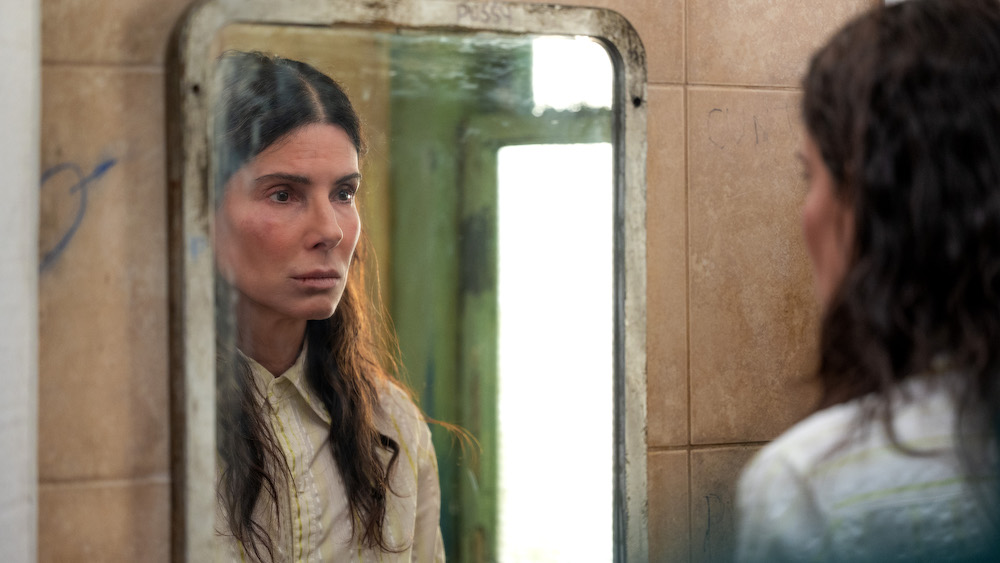Craft a story about the events that led her to be in this bathroom. Once a successful professional, she had it all: a thriving career, a loving family, and vibrant social circles. But life took an unexpected turn when her company faced a severe financial crisis, leading to layoffs. The stress took a toll on her relationships, causing them to crumble one by one. In a desperate attempt to hold her life together, she turned to temporary fixes, which only exacerbated the situation. She lost her home and now roams from place to place, seeking refuge wherever she can find it. This dilapidated bathroom, with its cracked mirror and graffiti-stained walls, is now a stark reminder of her precipitous fall from grace. As she looks at her reflection, she vows to rebuild her life from the ashes, driven by the memories of the happiness she once knew. 